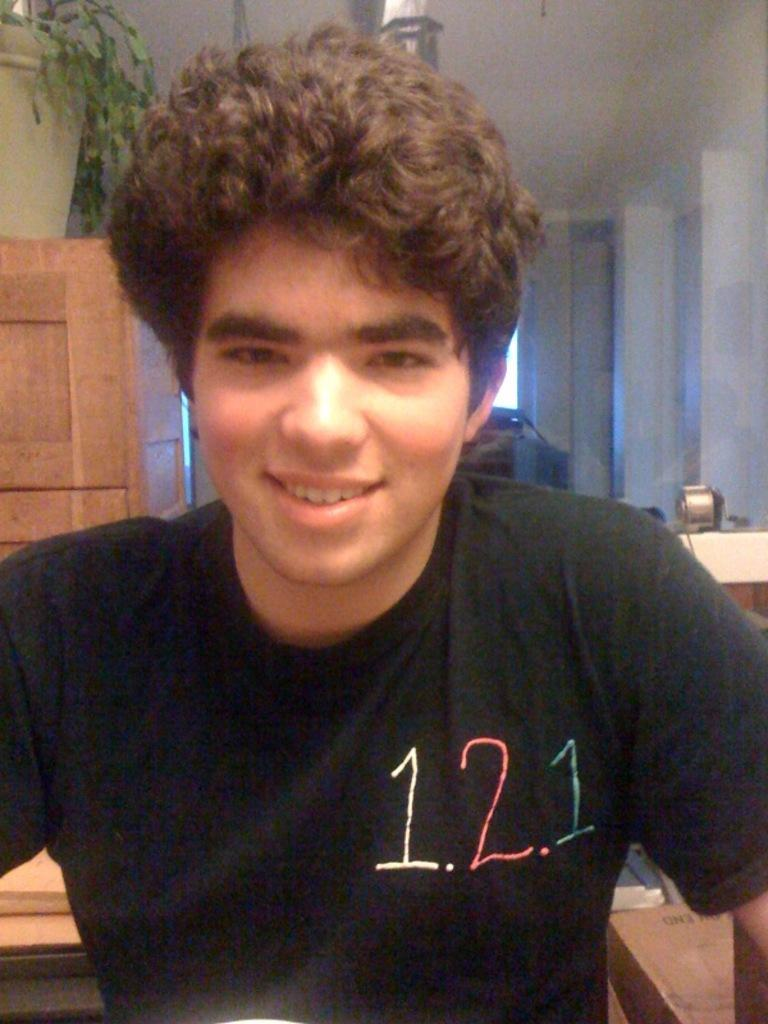Who is the main subject in the image? There is a man in the image. What is located behind the man? There is a wooden object behind the man. What is on the wooden object? There is a pot plant on the wooden object. What can be seen on the right side of the image? There is a wall on the right side of the image. How many secretaries does the man have in the image? There is no mention of a secretary in the image, so it cannot be determined how many the man has. 